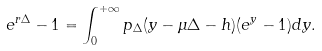<formula> <loc_0><loc_0><loc_500><loc_500>e ^ { r \Delta } - 1 = \int _ { 0 } ^ { + \infty } p _ { \Delta } ( y - \mu \Delta - h ) ( e ^ { y } - 1 ) d y .</formula> 